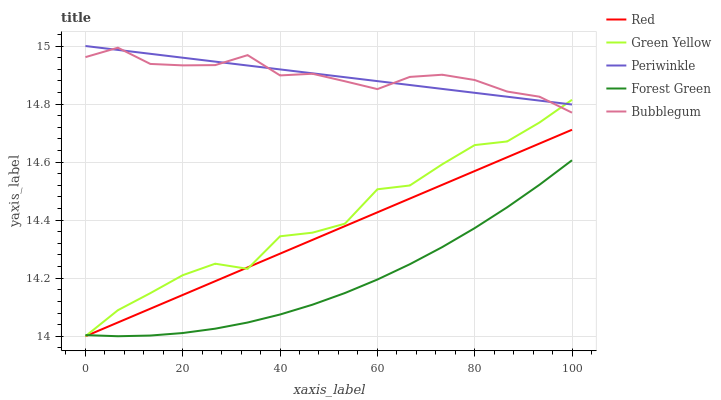Does Forest Green have the minimum area under the curve?
Answer yes or no. Yes. Does Bubblegum have the maximum area under the curve?
Answer yes or no. Yes. Does Green Yellow have the minimum area under the curve?
Answer yes or no. No. Does Green Yellow have the maximum area under the curve?
Answer yes or no. No. Is Periwinkle the smoothest?
Answer yes or no. Yes. Is Green Yellow the roughest?
Answer yes or no. Yes. Is Green Yellow the smoothest?
Answer yes or no. No. Is Periwinkle the roughest?
Answer yes or no. No. Does Green Yellow have the lowest value?
Answer yes or no. No. Does Periwinkle have the highest value?
Answer yes or no. Yes. Does Green Yellow have the highest value?
Answer yes or no. No. Is Red less than Bubblegum?
Answer yes or no. Yes. Is Periwinkle greater than Forest Green?
Answer yes or no. Yes. Does Green Yellow intersect Bubblegum?
Answer yes or no. Yes. Is Green Yellow less than Bubblegum?
Answer yes or no. No. Is Green Yellow greater than Bubblegum?
Answer yes or no. No. Does Red intersect Bubblegum?
Answer yes or no. No. 